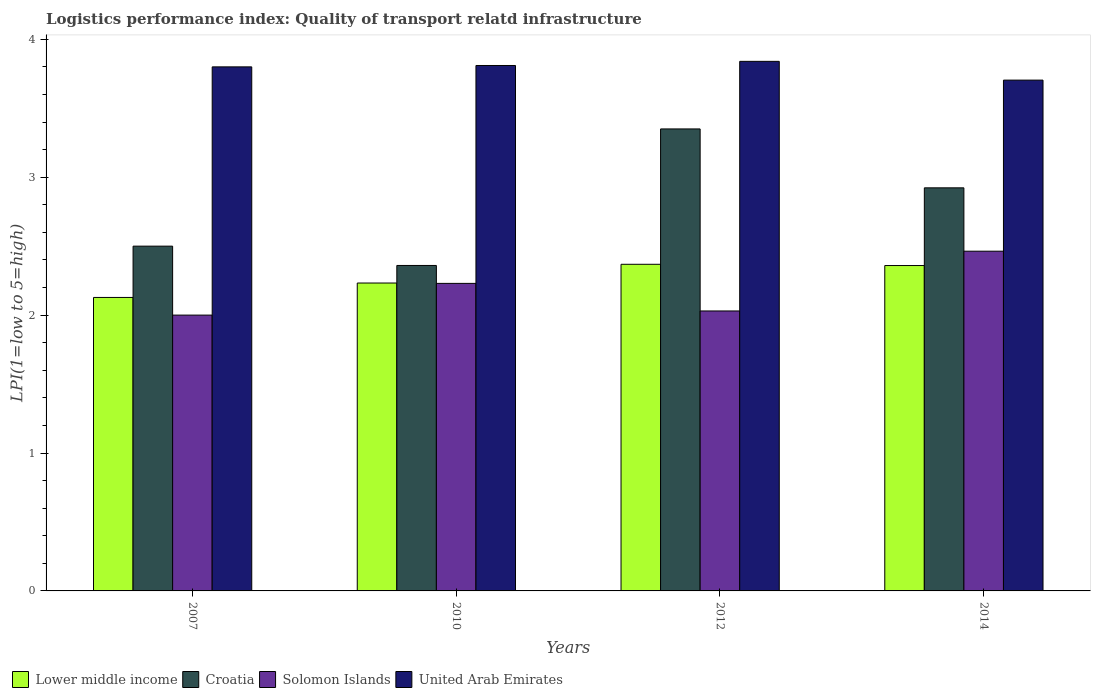How many different coloured bars are there?
Provide a succinct answer. 4. Are the number of bars per tick equal to the number of legend labels?
Offer a very short reply. Yes. Are the number of bars on each tick of the X-axis equal?
Keep it short and to the point. Yes. How many bars are there on the 1st tick from the left?
Offer a very short reply. 4. How many bars are there on the 2nd tick from the right?
Ensure brevity in your answer.  4. What is the label of the 1st group of bars from the left?
Make the answer very short. 2007. What is the logistics performance index in United Arab Emirates in 2010?
Provide a short and direct response. 3.81. Across all years, what is the maximum logistics performance index in Solomon Islands?
Provide a short and direct response. 2.46. Across all years, what is the minimum logistics performance index in United Arab Emirates?
Offer a terse response. 3.7. In which year was the logistics performance index in Croatia maximum?
Provide a short and direct response. 2012. What is the total logistics performance index in Croatia in the graph?
Keep it short and to the point. 11.13. What is the difference between the logistics performance index in Croatia in 2010 and that in 2014?
Make the answer very short. -0.56. What is the difference between the logistics performance index in United Arab Emirates in 2014 and the logistics performance index in Lower middle income in 2012?
Offer a terse response. 1.34. What is the average logistics performance index in United Arab Emirates per year?
Your answer should be compact. 3.79. In the year 2010, what is the difference between the logistics performance index in Solomon Islands and logistics performance index in United Arab Emirates?
Provide a succinct answer. -1.58. What is the ratio of the logistics performance index in Croatia in 2010 to that in 2012?
Give a very brief answer. 0.7. Is the difference between the logistics performance index in Solomon Islands in 2007 and 2012 greater than the difference between the logistics performance index in United Arab Emirates in 2007 and 2012?
Offer a terse response. Yes. What is the difference between the highest and the second highest logistics performance index in United Arab Emirates?
Offer a very short reply. 0.03. What is the difference between the highest and the lowest logistics performance index in Lower middle income?
Provide a succinct answer. 0.24. Is it the case that in every year, the sum of the logistics performance index in United Arab Emirates and logistics performance index in Solomon Islands is greater than the sum of logistics performance index in Croatia and logistics performance index in Lower middle income?
Your response must be concise. No. What does the 4th bar from the left in 2007 represents?
Give a very brief answer. United Arab Emirates. What does the 2nd bar from the right in 2007 represents?
Offer a terse response. Solomon Islands. How many bars are there?
Your response must be concise. 16. Are the values on the major ticks of Y-axis written in scientific E-notation?
Your answer should be compact. No. Does the graph contain any zero values?
Ensure brevity in your answer.  No. Does the graph contain grids?
Give a very brief answer. No. Where does the legend appear in the graph?
Your answer should be compact. Bottom left. What is the title of the graph?
Offer a terse response. Logistics performance index: Quality of transport relatd infrastructure. What is the label or title of the Y-axis?
Give a very brief answer. LPI(1=low to 5=high). What is the LPI(1=low to 5=high) of Lower middle income in 2007?
Provide a succinct answer. 2.13. What is the LPI(1=low to 5=high) of Croatia in 2007?
Make the answer very short. 2.5. What is the LPI(1=low to 5=high) of Solomon Islands in 2007?
Ensure brevity in your answer.  2. What is the LPI(1=low to 5=high) in Lower middle income in 2010?
Ensure brevity in your answer.  2.23. What is the LPI(1=low to 5=high) in Croatia in 2010?
Make the answer very short. 2.36. What is the LPI(1=low to 5=high) in Solomon Islands in 2010?
Offer a terse response. 2.23. What is the LPI(1=low to 5=high) in United Arab Emirates in 2010?
Your response must be concise. 3.81. What is the LPI(1=low to 5=high) of Lower middle income in 2012?
Ensure brevity in your answer.  2.37. What is the LPI(1=low to 5=high) in Croatia in 2012?
Your answer should be very brief. 3.35. What is the LPI(1=low to 5=high) in Solomon Islands in 2012?
Offer a terse response. 2.03. What is the LPI(1=low to 5=high) in United Arab Emirates in 2012?
Give a very brief answer. 3.84. What is the LPI(1=low to 5=high) in Lower middle income in 2014?
Keep it short and to the point. 2.36. What is the LPI(1=low to 5=high) of Croatia in 2014?
Ensure brevity in your answer.  2.92. What is the LPI(1=low to 5=high) in Solomon Islands in 2014?
Provide a succinct answer. 2.46. What is the LPI(1=low to 5=high) of United Arab Emirates in 2014?
Offer a very short reply. 3.7. Across all years, what is the maximum LPI(1=low to 5=high) of Lower middle income?
Your answer should be compact. 2.37. Across all years, what is the maximum LPI(1=low to 5=high) of Croatia?
Ensure brevity in your answer.  3.35. Across all years, what is the maximum LPI(1=low to 5=high) in Solomon Islands?
Your response must be concise. 2.46. Across all years, what is the maximum LPI(1=low to 5=high) in United Arab Emirates?
Your response must be concise. 3.84. Across all years, what is the minimum LPI(1=low to 5=high) in Lower middle income?
Your response must be concise. 2.13. Across all years, what is the minimum LPI(1=low to 5=high) in Croatia?
Your answer should be compact. 2.36. Across all years, what is the minimum LPI(1=low to 5=high) in United Arab Emirates?
Provide a short and direct response. 3.7. What is the total LPI(1=low to 5=high) of Lower middle income in the graph?
Keep it short and to the point. 9.09. What is the total LPI(1=low to 5=high) in Croatia in the graph?
Make the answer very short. 11.13. What is the total LPI(1=low to 5=high) of Solomon Islands in the graph?
Offer a terse response. 8.72. What is the total LPI(1=low to 5=high) of United Arab Emirates in the graph?
Offer a very short reply. 15.15. What is the difference between the LPI(1=low to 5=high) in Lower middle income in 2007 and that in 2010?
Your answer should be compact. -0.1. What is the difference between the LPI(1=low to 5=high) of Croatia in 2007 and that in 2010?
Offer a very short reply. 0.14. What is the difference between the LPI(1=low to 5=high) of Solomon Islands in 2007 and that in 2010?
Give a very brief answer. -0.23. What is the difference between the LPI(1=low to 5=high) in United Arab Emirates in 2007 and that in 2010?
Provide a succinct answer. -0.01. What is the difference between the LPI(1=low to 5=high) of Lower middle income in 2007 and that in 2012?
Keep it short and to the point. -0.24. What is the difference between the LPI(1=low to 5=high) of Croatia in 2007 and that in 2012?
Give a very brief answer. -0.85. What is the difference between the LPI(1=low to 5=high) in Solomon Islands in 2007 and that in 2012?
Offer a very short reply. -0.03. What is the difference between the LPI(1=low to 5=high) of United Arab Emirates in 2007 and that in 2012?
Make the answer very short. -0.04. What is the difference between the LPI(1=low to 5=high) of Lower middle income in 2007 and that in 2014?
Provide a succinct answer. -0.23. What is the difference between the LPI(1=low to 5=high) in Croatia in 2007 and that in 2014?
Offer a terse response. -0.42. What is the difference between the LPI(1=low to 5=high) in Solomon Islands in 2007 and that in 2014?
Give a very brief answer. -0.46. What is the difference between the LPI(1=low to 5=high) of United Arab Emirates in 2007 and that in 2014?
Give a very brief answer. 0.1. What is the difference between the LPI(1=low to 5=high) of Lower middle income in 2010 and that in 2012?
Your answer should be compact. -0.14. What is the difference between the LPI(1=low to 5=high) of Croatia in 2010 and that in 2012?
Provide a succinct answer. -0.99. What is the difference between the LPI(1=low to 5=high) in United Arab Emirates in 2010 and that in 2012?
Offer a very short reply. -0.03. What is the difference between the LPI(1=low to 5=high) of Lower middle income in 2010 and that in 2014?
Make the answer very short. -0.13. What is the difference between the LPI(1=low to 5=high) in Croatia in 2010 and that in 2014?
Your answer should be very brief. -0.56. What is the difference between the LPI(1=low to 5=high) of Solomon Islands in 2010 and that in 2014?
Your response must be concise. -0.23. What is the difference between the LPI(1=low to 5=high) of United Arab Emirates in 2010 and that in 2014?
Ensure brevity in your answer.  0.11. What is the difference between the LPI(1=low to 5=high) of Lower middle income in 2012 and that in 2014?
Your answer should be compact. 0.01. What is the difference between the LPI(1=low to 5=high) in Croatia in 2012 and that in 2014?
Offer a very short reply. 0.43. What is the difference between the LPI(1=low to 5=high) in Solomon Islands in 2012 and that in 2014?
Offer a very short reply. -0.43. What is the difference between the LPI(1=low to 5=high) of United Arab Emirates in 2012 and that in 2014?
Offer a terse response. 0.14. What is the difference between the LPI(1=low to 5=high) of Lower middle income in 2007 and the LPI(1=low to 5=high) of Croatia in 2010?
Give a very brief answer. -0.23. What is the difference between the LPI(1=low to 5=high) in Lower middle income in 2007 and the LPI(1=low to 5=high) in Solomon Islands in 2010?
Make the answer very short. -0.1. What is the difference between the LPI(1=low to 5=high) in Lower middle income in 2007 and the LPI(1=low to 5=high) in United Arab Emirates in 2010?
Ensure brevity in your answer.  -1.68. What is the difference between the LPI(1=low to 5=high) in Croatia in 2007 and the LPI(1=low to 5=high) in Solomon Islands in 2010?
Your answer should be compact. 0.27. What is the difference between the LPI(1=low to 5=high) of Croatia in 2007 and the LPI(1=low to 5=high) of United Arab Emirates in 2010?
Offer a very short reply. -1.31. What is the difference between the LPI(1=low to 5=high) in Solomon Islands in 2007 and the LPI(1=low to 5=high) in United Arab Emirates in 2010?
Your response must be concise. -1.81. What is the difference between the LPI(1=low to 5=high) of Lower middle income in 2007 and the LPI(1=low to 5=high) of Croatia in 2012?
Your answer should be compact. -1.22. What is the difference between the LPI(1=low to 5=high) in Lower middle income in 2007 and the LPI(1=low to 5=high) in Solomon Islands in 2012?
Give a very brief answer. 0.1. What is the difference between the LPI(1=low to 5=high) in Lower middle income in 2007 and the LPI(1=low to 5=high) in United Arab Emirates in 2012?
Provide a short and direct response. -1.71. What is the difference between the LPI(1=low to 5=high) in Croatia in 2007 and the LPI(1=low to 5=high) in Solomon Islands in 2012?
Your response must be concise. 0.47. What is the difference between the LPI(1=low to 5=high) in Croatia in 2007 and the LPI(1=low to 5=high) in United Arab Emirates in 2012?
Your response must be concise. -1.34. What is the difference between the LPI(1=low to 5=high) in Solomon Islands in 2007 and the LPI(1=low to 5=high) in United Arab Emirates in 2012?
Make the answer very short. -1.84. What is the difference between the LPI(1=low to 5=high) of Lower middle income in 2007 and the LPI(1=low to 5=high) of Croatia in 2014?
Your answer should be compact. -0.79. What is the difference between the LPI(1=low to 5=high) of Lower middle income in 2007 and the LPI(1=low to 5=high) of Solomon Islands in 2014?
Provide a short and direct response. -0.34. What is the difference between the LPI(1=low to 5=high) in Lower middle income in 2007 and the LPI(1=low to 5=high) in United Arab Emirates in 2014?
Provide a succinct answer. -1.58. What is the difference between the LPI(1=low to 5=high) of Croatia in 2007 and the LPI(1=low to 5=high) of Solomon Islands in 2014?
Ensure brevity in your answer.  0.04. What is the difference between the LPI(1=low to 5=high) in Croatia in 2007 and the LPI(1=low to 5=high) in United Arab Emirates in 2014?
Ensure brevity in your answer.  -1.2. What is the difference between the LPI(1=low to 5=high) of Solomon Islands in 2007 and the LPI(1=low to 5=high) of United Arab Emirates in 2014?
Your response must be concise. -1.7. What is the difference between the LPI(1=low to 5=high) in Lower middle income in 2010 and the LPI(1=low to 5=high) in Croatia in 2012?
Give a very brief answer. -1.12. What is the difference between the LPI(1=low to 5=high) of Lower middle income in 2010 and the LPI(1=low to 5=high) of Solomon Islands in 2012?
Give a very brief answer. 0.2. What is the difference between the LPI(1=low to 5=high) in Lower middle income in 2010 and the LPI(1=low to 5=high) in United Arab Emirates in 2012?
Keep it short and to the point. -1.61. What is the difference between the LPI(1=low to 5=high) of Croatia in 2010 and the LPI(1=low to 5=high) of Solomon Islands in 2012?
Your answer should be compact. 0.33. What is the difference between the LPI(1=low to 5=high) in Croatia in 2010 and the LPI(1=low to 5=high) in United Arab Emirates in 2012?
Provide a short and direct response. -1.48. What is the difference between the LPI(1=low to 5=high) in Solomon Islands in 2010 and the LPI(1=low to 5=high) in United Arab Emirates in 2012?
Make the answer very short. -1.61. What is the difference between the LPI(1=low to 5=high) of Lower middle income in 2010 and the LPI(1=low to 5=high) of Croatia in 2014?
Your answer should be compact. -0.69. What is the difference between the LPI(1=low to 5=high) of Lower middle income in 2010 and the LPI(1=low to 5=high) of Solomon Islands in 2014?
Your answer should be very brief. -0.23. What is the difference between the LPI(1=low to 5=high) of Lower middle income in 2010 and the LPI(1=low to 5=high) of United Arab Emirates in 2014?
Provide a succinct answer. -1.47. What is the difference between the LPI(1=low to 5=high) in Croatia in 2010 and the LPI(1=low to 5=high) in Solomon Islands in 2014?
Your response must be concise. -0.1. What is the difference between the LPI(1=low to 5=high) of Croatia in 2010 and the LPI(1=low to 5=high) of United Arab Emirates in 2014?
Give a very brief answer. -1.34. What is the difference between the LPI(1=low to 5=high) of Solomon Islands in 2010 and the LPI(1=low to 5=high) of United Arab Emirates in 2014?
Your response must be concise. -1.47. What is the difference between the LPI(1=low to 5=high) of Lower middle income in 2012 and the LPI(1=low to 5=high) of Croatia in 2014?
Your answer should be compact. -0.55. What is the difference between the LPI(1=low to 5=high) in Lower middle income in 2012 and the LPI(1=low to 5=high) in Solomon Islands in 2014?
Provide a succinct answer. -0.09. What is the difference between the LPI(1=low to 5=high) in Lower middle income in 2012 and the LPI(1=low to 5=high) in United Arab Emirates in 2014?
Give a very brief answer. -1.34. What is the difference between the LPI(1=low to 5=high) in Croatia in 2012 and the LPI(1=low to 5=high) in Solomon Islands in 2014?
Offer a terse response. 0.89. What is the difference between the LPI(1=low to 5=high) in Croatia in 2012 and the LPI(1=low to 5=high) in United Arab Emirates in 2014?
Your answer should be very brief. -0.35. What is the difference between the LPI(1=low to 5=high) of Solomon Islands in 2012 and the LPI(1=low to 5=high) of United Arab Emirates in 2014?
Your answer should be compact. -1.67. What is the average LPI(1=low to 5=high) in Lower middle income per year?
Provide a succinct answer. 2.27. What is the average LPI(1=low to 5=high) in Croatia per year?
Offer a terse response. 2.78. What is the average LPI(1=low to 5=high) in Solomon Islands per year?
Your response must be concise. 2.18. What is the average LPI(1=low to 5=high) in United Arab Emirates per year?
Provide a short and direct response. 3.79. In the year 2007, what is the difference between the LPI(1=low to 5=high) in Lower middle income and LPI(1=low to 5=high) in Croatia?
Keep it short and to the point. -0.37. In the year 2007, what is the difference between the LPI(1=low to 5=high) in Lower middle income and LPI(1=low to 5=high) in Solomon Islands?
Make the answer very short. 0.13. In the year 2007, what is the difference between the LPI(1=low to 5=high) of Lower middle income and LPI(1=low to 5=high) of United Arab Emirates?
Keep it short and to the point. -1.67. In the year 2007, what is the difference between the LPI(1=low to 5=high) of Croatia and LPI(1=low to 5=high) of Solomon Islands?
Provide a succinct answer. 0.5. In the year 2007, what is the difference between the LPI(1=low to 5=high) of Croatia and LPI(1=low to 5=high) of United Arab Emirates?
Offer a very short reply. -1.3. In the year 2007, what is the difference between the LPI(1=low to 5=high) of Solomon Islands and LPI(1=low to 5=high) of United Arab Emirates?
Your response must be concise. -1.8. In the year 2010, what is the difference between the LPI(1=low to 5=high) of Lower middle income and LPI(1=low to 5=high) of Croatia?
Make the answer very short. -0.13. In the year 2010, what is the difference between the LPI(1=low to 5=high) of Lower middle income and LPI(1=low to 5=high) of Solomon Islands?
Your response must be concise. 0. In the year 2010, what is the difference between the LPI(1=low to 5=high) of Lower middle income and LPI(1=low to 5=high) of United Arab Emirates?
Your answer should be very brief. -1.58. In the year 2010, what is the difference between the LPI(1=low to 5=high) of Croatia and LPI(1=low to 5=high) of Solomon Islands?
Your answer should be compact. 0.13. In the year 2010, what is the difference between the LPI(1=low to 5=high) of Croatia and LPI(1=low to 5=high) of United Arab Emirates?
Your response must be concise. -1.45. In the year 2010, what is the difference between the LPI(1=low to 5=high) of Solomon Islands and LPI(1=low to 5=high) of United Arab Emirates?
Your answer should be very brief. -1.58. In the year 2012, what is the difference between the LPI(1=low to 5=high) in Lower middle income and LPI(1=low to 5=high) in Croatia?
Provide a short and direct response. -0.98. In the year 2012, what is the difference between the LPI(1=low to 5=high) in Lower middle income and LPI(1=low to 5=high) in Solomon Islands?
Your response must be concise. 0.34. In the year 2012, what is the difference between the LPI(1=low to 5=high) in Lower middle income and LPI(1=low to 5=high) in United Arab Emirates?
Your response must be concise. -1.47. In the year 2012, what is the difference between the LPI(1=low to 5=high) of Croatia and LPI(1=low to 5=high) of Solomon Islands?
Give a very brief answer. 1.32. In the year 2012, what is the difference between the LPI(1=low to 5=high) of Croatia and LPI(1=low to 5=high) of United Arab Emirates?
Your answer should be compact. -0.49. In the year 2012, what is the difference between the LPI(1=low to 5=high) in Solomon Islands and LPI(1=low to 5=high) in United Arab Emirates?
Ensure brevity in your answer.  -1.81. In the year 2014, what is the difference between the LPI(1=low to 5=high) in Lower middle income and LPI(1=low to 5=high) in Croatia?
Your answer should be compact. -0.56. In the year 2014, what is the difference between the LPI(1=low to 5=high) of Lower middle income and LPI(1=low to 5=high) of Solomon Islands?
Keep it short and to the point. -0.1. In the year 2014, what is the difference between the LPI(1=low to 5=high) in Lower middle income and LPI(1=low to 5=high) in United Arab Emirates?
Make the answer very short. -1.34. In the year 2014, what is the difference between the LPI(1=low to 5=high) of Croatia and LPI(1=low to 5=high) of Solomon Islands?
Offer a very short reply. 0.46. In the year 2014, what is the difference between the LPI(1=low to 5=high) of Croatia and LPI(1=low to 5=high) of United Arab Emirates?
Offer a terse response. -0.78. In the year 2014, what is the difference between the LPI(1=low to 5=high) of Solomon Islands and LPI(1=low to 5=high) of United Arab Emirates?
Give a very brief answer. -1.24. What is the ratio of the LPI(1=low to 5=high) of Lower middle income in 2007 to that in 2010?
Provide a succinct answer. 0.95. What is the ratio of the LPI(1=low to 5=high) in Croatia in 2007 to that in 2010?
Provide a succinct answer. 1.06. What is the ratio of the LPI(1=low to 5=high) in Solomon Islands in 2007 to that in 2010?
Your answer should be very brief. 0.9. What is the ratio of the LPI(1=low to 5=high) in Lower middle income in 2007 to that in 2012?
Provide a short and direct response. 0.9. What is the ratio of the LPI(1=low to 5=high) in Croatia in 2007 to that in 2012?
Ensure brevity in your answer.  0.75. What is the ratio of the LPI(1=low to 5=high) in Solomon Islands in 2007 to that in 2012?
Ensure brevity in your answer.  0.99. What is the ratio of the LPI(1=low to 5=high) in Lower middle income in 2007 to that in 2014?
Your answer should be very brief. 0.9. What is the ratio of the LPI(1=low to 5=high) in Croatia in 2007 to that in 2014?
Make the answer very short. 0.86. What is the ratio of the LPI(1=low to 5=high) in Solomon Islands in 2007 to that in 2014?
Your response must be concise. 0.81. What is the ratio of the LPI(1=low to 5=high) in United Arab Emirates in 2007 to that in 2014?
Provide a short and direct response. 1.03. What is the ratio of the LPI(1=low to 5=high) of Lower middle income in 2010 to that in 2012?
Your response must be concise. 0.94. What is the ratio of the LPI(1=low to 5=high) in Croatia in 2010 to that in 2012?
Offer a terse response. 0.7. What is the ratio of the LPI(1=low to 5=high) in Solomon Islands in 2010 to that in 2012?
Keep it short and to the point. 1.1. What is the ratio of the LPI(1=low to 5=high) in Lower middle income in 2010 to that in 2014?
Make the answer very short. 0.95. What is the ratio of the LPI(1=low to 5=high) in Croatia in 2010 to that in 2014?
Make the answer very short. 0.81. What is the ratio of the LPI(1=low to 5=high) in Solomon Islands in 2010 to that in 2014?
Provide a succinct answer. 0.91. What is the ratio of the LPI(1=low to 5=high) in United Arab Emirates in 2010 to that in 2014?
Give a very brief answer. 1.03. What is the ratio of the LPI(1=low to 5=high) of Lower middle income in 2012 to that in 2014?
Ensure brevity in your answer.  1. What is the ratio of the LPI(1=low to 5=high) of Croatia in 2012 to that in 2014?
Provide a short and direct response. 1.15. What is the ratio of the LPI(1=low to 5=high) in Solomon Islands in 2012 to that in 2014?
Give a very brief answer. 0.82. What is the ratio of the LPI(1=low to 5=high) of United Arab Emirates in 2012 to that in 2014?
Provide a succinct answer. 1.04. What is the difference between the highest and the second highest LPI(1=low to 5=high) of Lower middle income?
Your answer should be very brief. 0.01. What is the difference between the highest and the second highest LPI(1=low to 5=high) in Croatia?
Provide a succinct answer. 0.43. What is the difference between the highest and the second highest LPI(1=low to 5=high) of Solomon Islands?
Provide a short and direct response. 0.23. What is the difference between the highest and the lowest LPI(1=low to 5=high) of Lower middle income?
Provide a succinct answer. 0.24. What is the difference between the highest and the lowest LPI(1=low to 5=high) in Solomon Islands?
Provide a short and direct response. 0.46. What is the difference between the highest and the lowest LPI(1=low to 5=high) in United Arab Emirates?
Offer a very short reply. 0.14. 